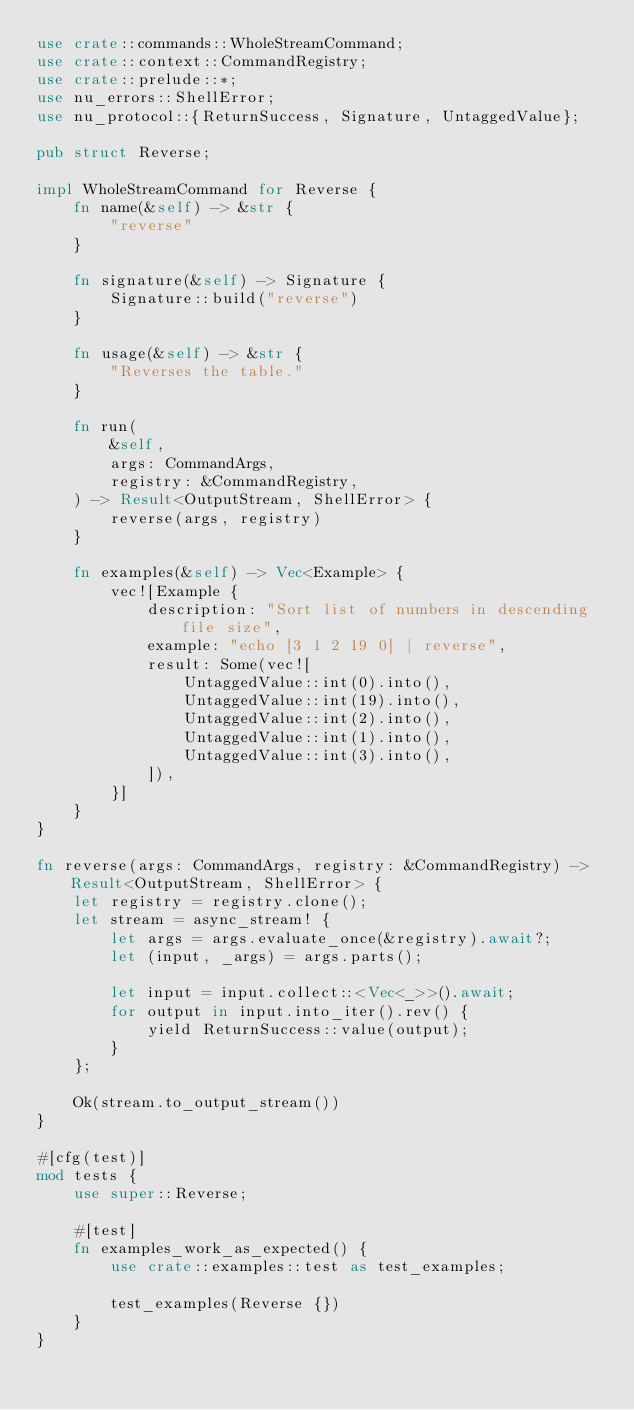Convert code to text. <code><loc_0><loc_0><loc_500><loc_500><_Rust_>use crate::commands::WholeStreamCommand;
use crate::context::CommandRegistry;
use crate::prelude::*;
use nu_errors::ShellError;
use nu_protocol::{ReturnSuccess, Signature, UntaggedValue};

pub struct Reverse;

impl WholeStreamCommand for Reverse {
    fn name(&self) -> &str {
        "reverse"
    }

    fn signature(&self) -> Signature {
        Signature::build("reverse")
    }

    fn usage(&self) -> &str {
        "Reverses the table."
    }

    fn run(
        &self,
        args: CommandArgs,
        registry: &CommandRegistry,
    ) -> Result<OutputStream, ShellError> {
        reverse(args, registry)
    }

    fn examples(&self) -> Vec<Example> {
        vec![Example {
            description: "Sort list of numbers in descending file size",
            example: "echo [3 1 2 19 0] | reverse",
            result: Some(vec![
                UntaggedValue::int(0).into(),
                UntaggedValue::int(19).into(),
                UntaggedValue::int(2).into(),
                UntaggedValue::int(1).into(),
                UntaggedValue::int(3).into(),
            ]),
        }]
    }
}

fn reverse(args: CommandArgs, registry: &CommandRegistry) -> Result<OutputStream, ShellError> {
    let registry = registry.clone();
    let stream = async_stream! {
        let args = args.evaluate_once(&registry).await?;
        let (input, _args) = args.parts();

        let input = input.collect::<Vec<_>>().await;
        for output in input.into_iter().rev() {
            yield ReturnSuccess::value(output);
        }
    };

    Ok(stream.to_output_stream())
}

#[cfg(test)]
mod tests {
    use super::Reverse;

    #[test]
    fn examples_work_as_expected() {
        use crate::examples::test as test_examples;

        test_examples(Reverse {})
    }
}
</code> 